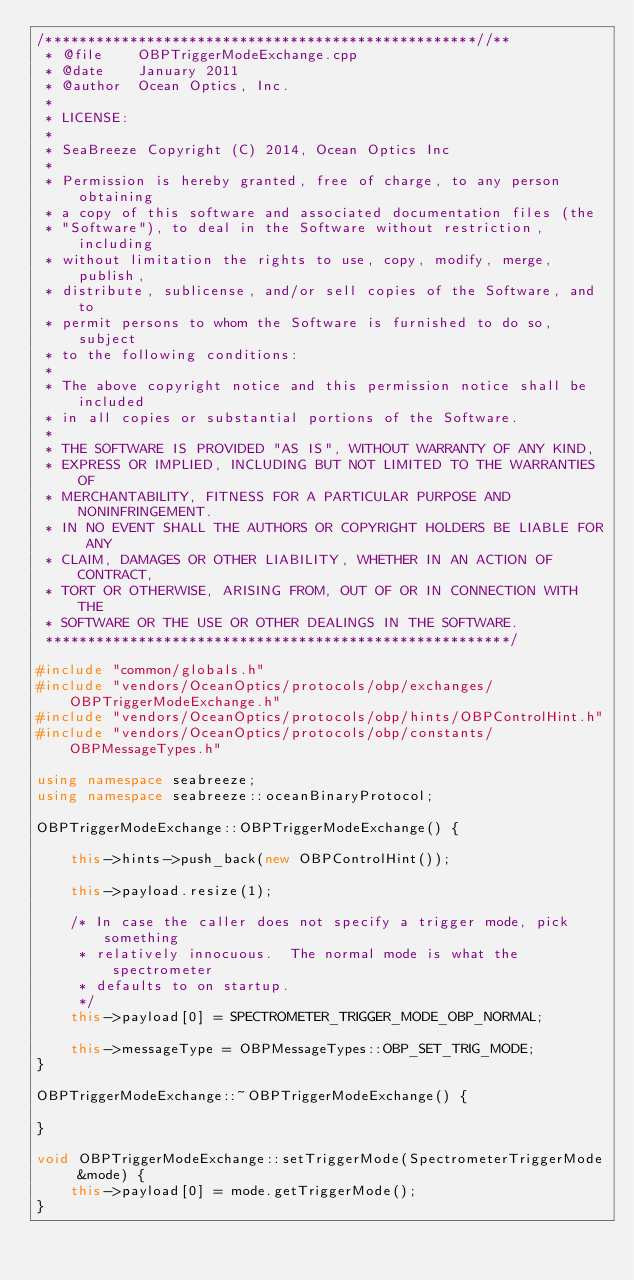Convert code to text. <code><loc_0><loc_0><loc_500><loc_500><_C++_>/***************************************************//**
 * @file    OBPTriggerModeExchange.cpp
 * @date    January 2011
 * @author  Ocean Optics, Inc.
 *
 * LICENSE:
 *
 * SeaBreeze Copyright (C) 2014, Ocean Optics Inc
 *
 * Permission is hereby granted, free of charge, to any person obtaining
 * a copy of this software and associated documentation files (the
 * "Software"), to deal in the Software without restriction, including
 * without limitation the rights to use, copy, modify, merge, publish,
 * distribute, sublicense, and/or sell copies of the Software, and to
 * permit persons to whom the Software is furnished to do so, subject
 * to the following conditions:
 *
 * The above copyright notice and this permission notice shall be included
 * in all copies or substantial portions of the Software.
 *
 * THE SOFTWARE IS PROVIDED "AS IS", WITHOUT WARRANTY OF ANY KIND,
 * EXPRESS OR IMPLIED, INCLUDING BUT NOT LIMITED TO THE WARRANTIES OF
 * MERCHANTABILITY, FITNESS FOR A PARTICULAR PURPOSE AND NONINFRINGEMENT.
 * IN NO EVENT SHALL THE AUTHORS OR COPYRIGHT HOLDERS BE LIABLE FOR ANY
 * CLAIM, DAMAGES OR OTHER LIABILITY, WHETHER IN AN ACTION OF CONTRACT,
 * TORT OR OTHERWISE, ARISING FROM, OUT OF OR IN CONNECTION WITH THE
 * SOFTWARE OR THE USE OR OTHER DEALINGS IN THE SOFTWARE.
 *******************************************************/

#include "common/globals.h"
#include "vendors/OceanOptics/protocols/obp/exchanges/OBPTriggerModeExchange.h"
#include "vendors/OceanOptics/protocols/obp/hints/OBPControlHint.h"
#include "vendors/OceanOptics/protocols/obp/constants/OBPMessageTypes.h"

using namespace seabreeze;
using namespace seabreeze::oceanBinaryProtocol;

OBPTriggerModeExchange::OBPTriggerModeExchange() {

    this->hints->push_back(new OBPControlHint());

    this->payload.resize(1);

    /* In case the caller does not specify a trigger mode, pick something
     * relatively innocuous.  The normal mode is what the spectrometer
     * defaults to on startup.
     */
    this->payload[0] = SPECTROMETER_TRIGGER_MODE_OBP_NORMAL;

    this->messageType = OBPMessageTypes::OBP_SET_TRIG_MODE;
}

OBPTriggerModeExchange::~OBPTriggerModeExchange() {

}

void OBPTriggerModeExchange::setTriggerMode(SpectrometerTriggerMode &mode) {
    this->payload[0] = mode.getTriggerMode();
}
</code> 